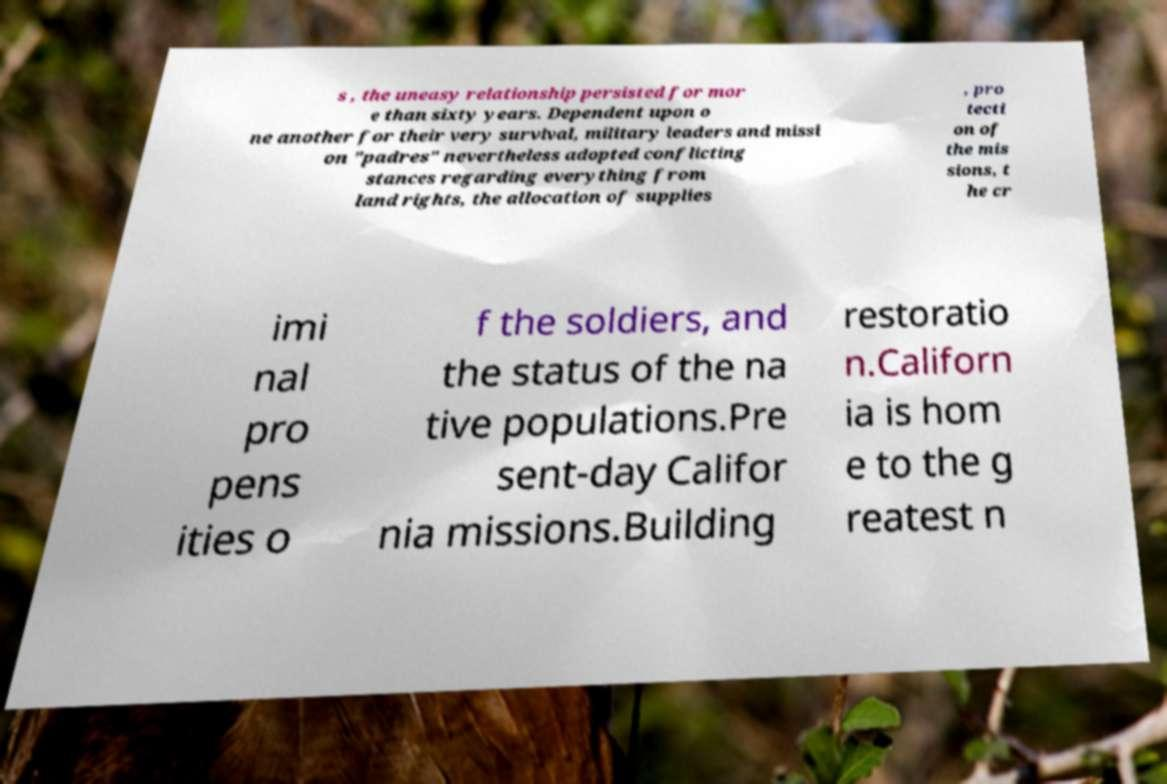What messages or text are displayed in this image? I need them in a readable, typed format. s , the uneasy relationship persisted for mor e than sixty years. Dependent upon o ne another for their very survival, military leaders and missi on "padres" nevertheless adopted conflicting stances regarding everything from land rights, the allocation of supplies , pro tecti on of the mis sions, t he cr imi nal pro pens ities o f the soldiers, and the status of the na tive populations.Pre sent-day Califor nia missions.Building restoratio n.Californ ia is hom e to the g reatest n 